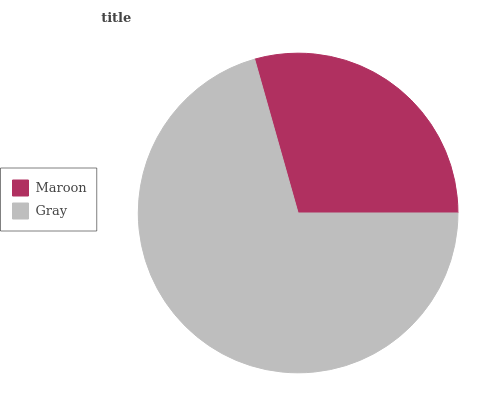Is Maroon the minimum?
Answer yes or no. Yes. Is Gray the maximum?
Answer yes or no. Yes. Is Gray the minimum?
Answer yes or no. No. Is Gray greater than Maroon?
Answer yes or no. Yes. Is Maroon less than Gray?
Answer yes or no. Yes. Is Maroon greater than Gray?
Answer yes or no. No. Is Gray less than Maroon?
Answer yes or no. No. Is Gray the high median?
Answer yes or no. Yes. Is Maroon the low median?
Answer yes or no. Yes. Is Maroon the high median?
Answer yes or no. No. Is Gray the low median?
Answer yes or no. No. 